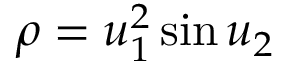<formula> <loc_0><loc_0><loc_500><loc_500>\rho = u _ { 1 } ^ { 2 } \sin u _ { 2 }</formula> 